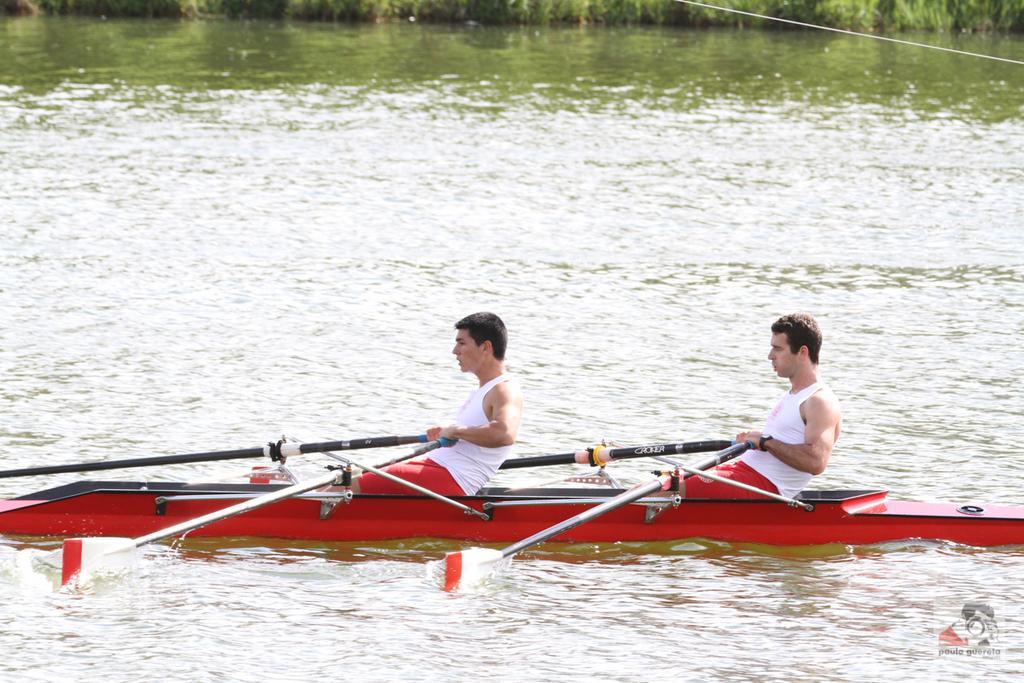How would you summarize this image in a sentence or two? In this image there are two persons rowing the boat in the water. At the back side there's grass on the surface. 